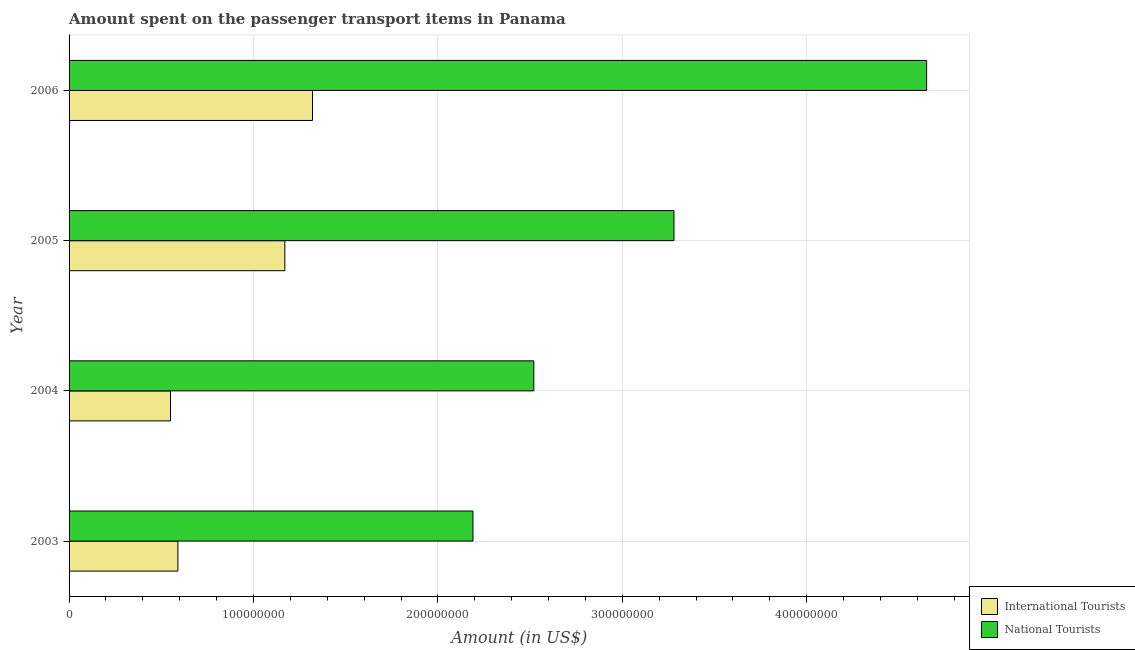How many different coloured bars are there?
Give a very brief answer. 2. How many groups of bars are there?
Your answer should be very brief. 4. Are the number of bars per tick equal to the number of legend labels?
Make the answer very short. Yes. How many bars are there on the 2nd tick from the top?
Make the answer very short. 2. In how many cases, is the number of bars for a given year not equal to the number of legend labels?
Give a very brief answer. 0. What is the amount spent on transport items of national tourists in 2005?
Your answer should be very brief. 3.28e+08. Across all years, what is the maximum amount spent on transport items of national tourists?
Offer a terse response. 4.65e+08. Across all years, what is the minimum amount spent on transport items of international tourists?
Offer a terse response. 5.50e+07. In which year was the amount spent on transport items of international tourists minimum?
Give a very brief answer. 2004. What is the total amount spent on transport items of international tourists in the graph?
Your response must be concise. 3.63e+08. What is the difference between the amount spent on transport items of national tourists in 2003 and that in 2004?
Offer a very short reply. -3.30e+07. What is the difference between the amount spent on transport items of national tourists in 2004 and the amount spent on transport items of international tourists in 2005?
Provide a short and direct response. 1.35e+08. What is the average amount spent on transport items of international tourists per year?
Provide a succinct answer. 9.08e+07. In the year 2003, what is the difference between the amount spent on transport items of national tourists and amount spent on transport items of international tourists?
Your answer should be very brief. 1.60e+08. What is the ratio of the amount spent on transport items of national tourists in 2004 to that in 2006?
Make the answer very short. 0.54. Is the difference between the amount spent on transport items of national tourists in 2004 and 2006 greater than the difference between the amount spent on transport items of international tourists in 2004 and 2006?
Your response must be concise. No. What is the difference between the highest and the second highest amount spent on transport items of international tourists?
Your response must be concise. 1.50e+07. What is the difference between the highest and the lowest amount spent on transport items of international tourists?
Provide a succinct answer. 7.70e+07. What does the 1st bar from the top in 2005 represents?
Provide a short and direct response. National Tourists. What does the 1st bar from the bottom in 2005 represents?
Offer a very short reply. International Tourists. How many bars are there?
Your answer should be very brief. 8. Are all the bars in the graph horizontal?
Provide a short and direct response. Yes. What is the difference between two consecutive major ticks on the X-axis?
Make the answer very short. 1.00e+08. Does the graph contain grids?
Keep it short and to the point. Yes. Where does the legend appear in the graph?
Your answer should be very brief. Bottom right. How are the legend labels stacked?
Give a very brief answer. Vertical. What is the title of the graph?
Offer a terse response. Amount spent on the passenger transport items in Panama. What is the Amount (in US$) in International Tourists in 2003?
Your answer should be very brief. 5.90e+07. What is the Amount (in US$) of National Tourists in 2003?
Offer a terse response. 2.19e+08. What is the Amount (in US$) in International Tourists in 2004?
Your answer should be very brief. 5.50e+07. What is the Amount (in US$) of National Tourists in 2004?
Your answer should be compact. 2.52e+08. What is the Amount (in US$) in International Tourists in 2005?
Your answer should be compact. 1.17e+08. What is the Amount (in US$) of National Tourists in 2005?
Give a very brief answer. 3.28e+08. What is the Amount (in US$) of International Tourists in 2006?
Make the answer very short. 1.32e+08. What is the Amount (in US$) of National Tourists in 2006?
Keep it short and to the point. 4.65e+08. Across all years, what is the maximum Amount (in US$) in International Tourists?
Provide a succinct answer. 1.32e+08. Across all years, what is the maximum Amount (in US$) of National Tourists?
Make the answer very short. 4.65e+08. Across all years, what is the minimum Amount (in US$) in International Tourists?
Your answer should be compact. 5.50e+07. Across all years, what is the minimum Amount (in US$) of National Tourists?
Make the answer very short. 2.19e+08. What is the total Amount (in US$) in International Tourists in the graph?
Your answer should be compact. 3.63e+08. What is the total Amount (in US$) of National Tourists in the graph?
Offer a very short reply. 1.26e+09. What is the difference between the Amount (in US$) in National Tourists in 2003 and that in 2004?
Offer a very short reply. -3.30e+07. What is the difference between the Amount (in US$) in International Tourists in 2003 and that in 2005?
Your answer should be compact. -5.80e+07. What is the difference between the Amount (in US$) of National Tourists in 2003 and that in 2005?
Your answer should be compact. -1.09e+08. What is the difference between the Amount (in US$) in International Tourists in 2003 and that in 2006?
Your answer should be compact. -7.30e+07. What is the difference between the Amount (in US$) in National Tourists in 2003 and that in 2006?
Offer a terse response. -2.46e+08. What is the difference between the Amount (in US$) in International Tourists in 2004 and that in 2005?
Offer a very short reply. -6.20e+07. What is the difference between the Amount (in US$) of National Tourists in 2004 and that in 2005?
Offer a terse response. -7.60e+07. What is the difference between the Amount (in US$) in International Tourists in 2004 and that in 2006?
Keep it short and to the point. -7.70e+07. What is the difference between the Amount (in US$) of National Tourists in 2004 and that in 2006?
Your answer should be compact. -2.13e+08. What is the difference between the Amount (in US$) in International Tourists in 2005 and that in 2006?
Your answer should be compact. -1.50e+07. What is the difference between the Amount (in US$) in National Tourists in 2005 and that in 2006?
Provide a succinct answer. -1.37e+08. What is the difference between the Amount (in US$) in International Tourists in 2003 and the Amount (in US$) in National Tourists in 2004?
Offer a terse response. -1.93e+08. What is the difference between the Amount (in US$) of International Tourists in 2003 and the Amount (in US$) of National Tourists in 2005?
Keep it short and to the point. -2.69e+08. What is the difference between the Amount (in US$) in International Tourists in 2003 and the Amount (in US$) in National Tourists in 2006?
Provide a succinct answer. -4.06e+08. What is the difference between the Amount (in US$) of International Tourists in 2004 and the Amount (in US$) of National Tourists in 2005?
Provide a short and direct response. -2.73e+08. What is the difference between the Amount (in US$) of International Tourists in 2004 and the Amount (in US$) of National Tourists in 2006?
Your answer should be compact. -4.10e+08. What is the difference between the Amount (in US$) in International Tourists in 2005 and the Amount (in US$) in National Tourists in 2006?
Offer a terse response. -3.48e+08. What is the average Amount (in US$) in International Tourists per year?
Offer a terse response. 9.08e+07. What is the average Amount (in US$) in National Tourists per year?
Offer a terse response. 3.16e+08. In the year 2003, what is the difference between the Amount (in US$) in International Tourists and Amount (in US$) in National Tourists?
Offer a terse response. -1.60e+08. In the year 2004, what is the difference between the Amount (in US$) in International Tourists and Amount (in US$) in National Tourists?
Give a very brief answer. -1.97e+08. In the year 2005, what is the difference between the Amount (in US$) of International Tourists and Amount (in US$) of National Tourists?
Give a very brief answer. -2.11e+08. In the year 2006, what is the difference between the Amount (in US$) in International Tourists and Amount (in US$) in National Tourists?
Your answer should be compact. -3.33e+08. What is the ratio of the Amount (in US$) in International Tourists in 2003 to that in 2004?
Provide a succinct answer. 1.07. What is the ratio of the Amount (in US$) of National Tourists in 2003 to that in 2004?
Give a very brief answer. 0.87. What is the ratio of the Amount (in US$) in International Tourists in 2003 to that in 2005?
Your response must be concise. 0.5. What is the ratio of the Amount (in US$) of National Tourists in 2003 to that in 2005?
Ensure brevity in your answer.  0.67. What is the ratio of the Amount (in US$) of International Tourists in 2003 to that in 2006?
Provide a short and direct response. 0.45. What is the ratio of the Amount (in US$) in National Tourists in 2003 to that in 2006?
Make the answer very short. 0.47. What is the ratio of the Amount (in US$) in International Tourists in 2004 to that in 2005?
Make the answer very short. 0.47. What is the ratio of the Amount (in US$) in National Tourists in 2004 to that in 2005?
Make the answer very short. 0.77. What is the ratio of the Amount (in US$) of International Tourists in 2004 to that in 2006?
Give a very brief answer. 0.42. What is the ratio of the Amount (in US$) of National Tourists in 2004 to that in 2006?
Keep it short and to the point. 0.54. What is the ratio of the Amount (in US$) in International Tourists in 2005 to that in 2006?
Make the answer very short. 0.89. What is the ratio of the Amount (in US$) of National Tourists in 2005 to that in 2006?
Offer a very short reply. 0.71. What is the difference between the highest and the second highest Amount (in US$) in International Tourists?
Give a very brief answer. 1.50e+07. What is the difference between the highest and the second highest Amount (in US$) in National Tourists?
Offer a very short reply. 1.37e+08. What is the difference between the highest and the lowest Amount (in US$) of International Tourists?
Keep it short and to the point. 7.70e+07. What is the difference between the highest and the lowest Amount (in US$) of National Tourists?
Make the answer very short. 2.46e+08. 